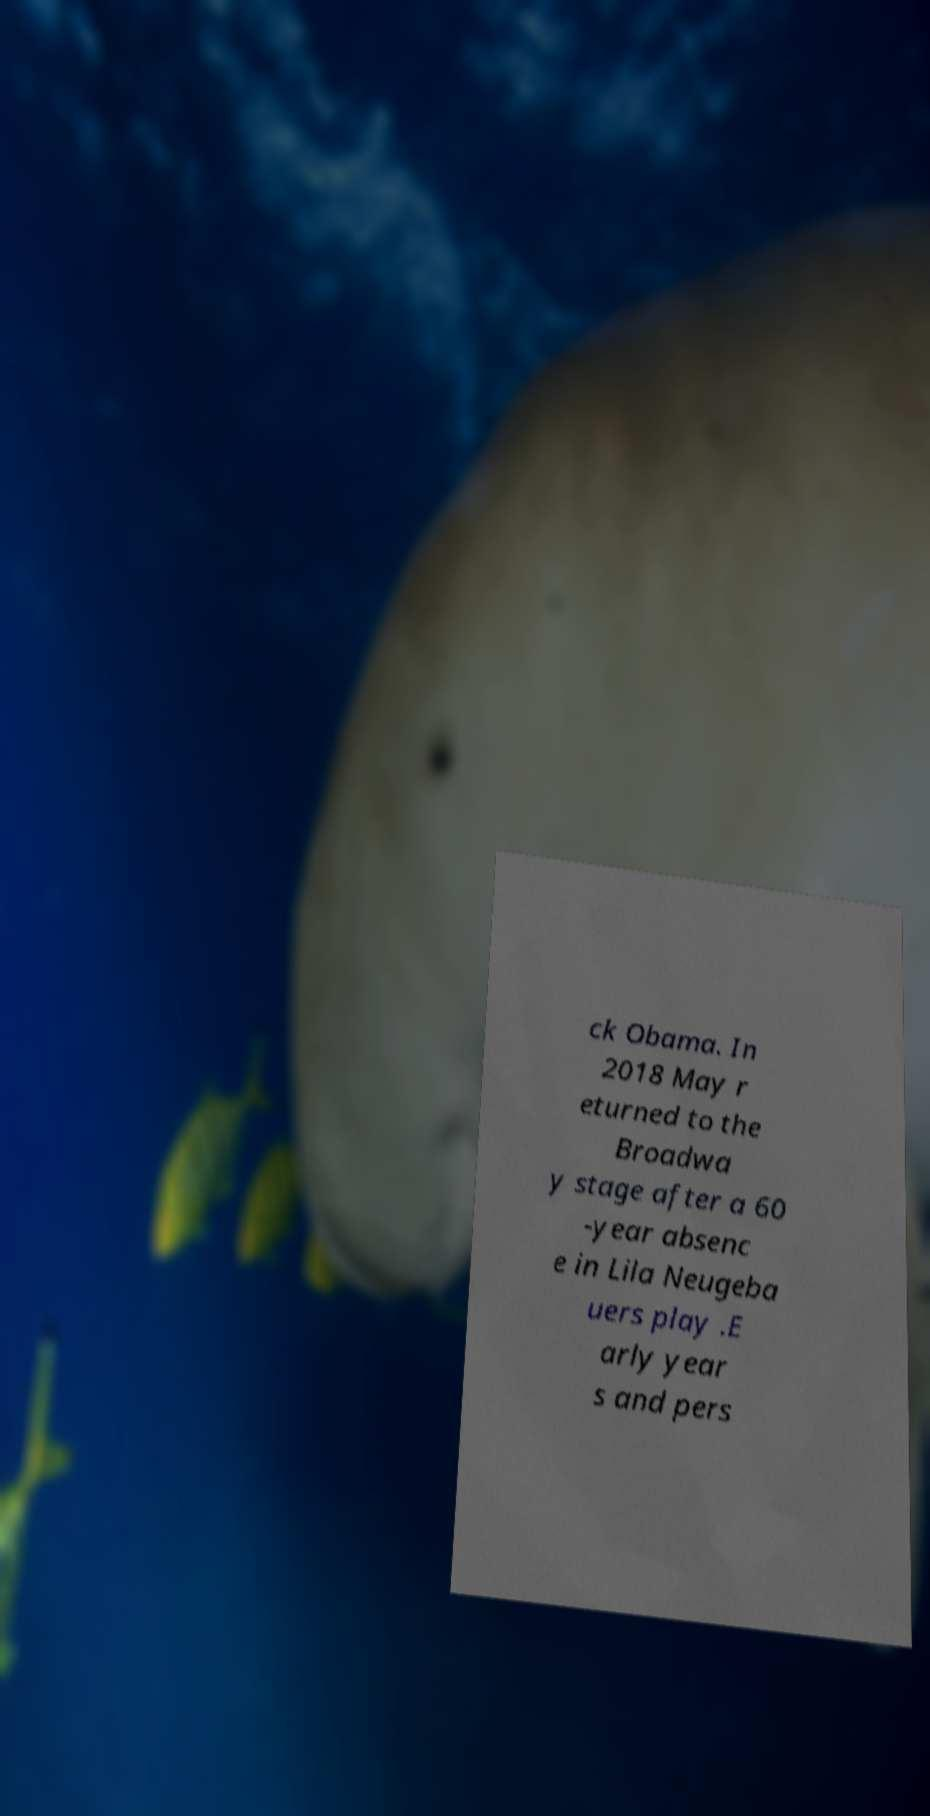I need the written content from this picture converted into text. Can you do that? ck Obama. In 2018 May r eturned to the Broadwa y stage after a 60 -year absenc e in Lila Neugeba uers play .E arly year s and pers 